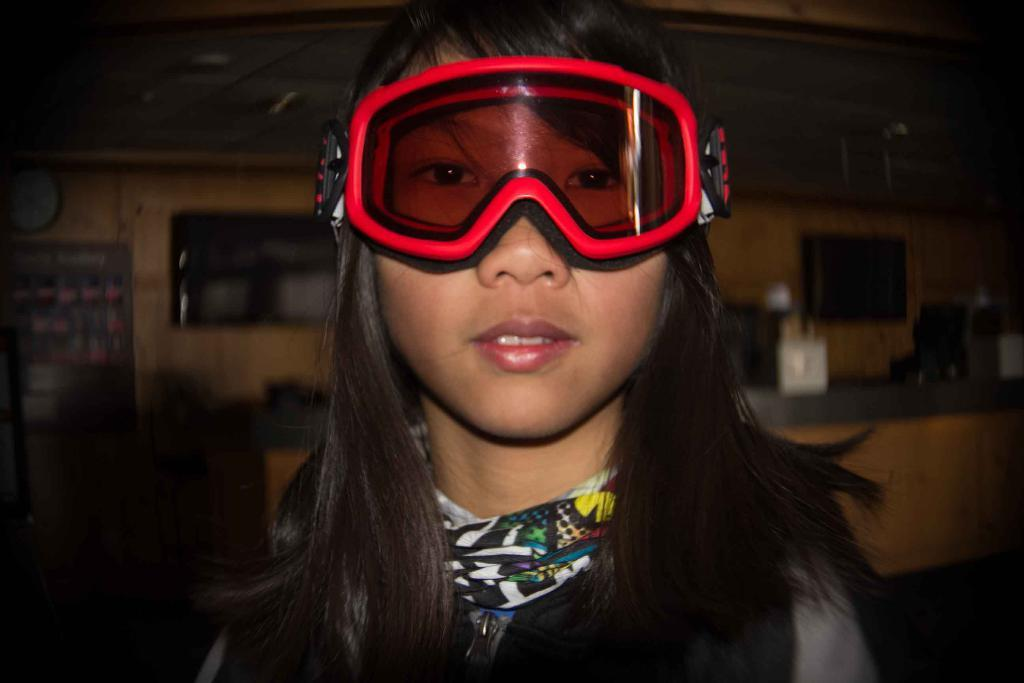Who is the main subject in the image? There is a girl in the image. What is the girl wearing on her face? The girl is wearing red color goggles. What accessory is the girl wearing around her neck? The girl is wearing a scarf around her neck. What can be inferred about the setting of the image? The background appears to be a kitchen. What type of respect does the girl show to her father in the image? There is no father present in the image, and therefore no interaction between the girl and her father can be observed. 